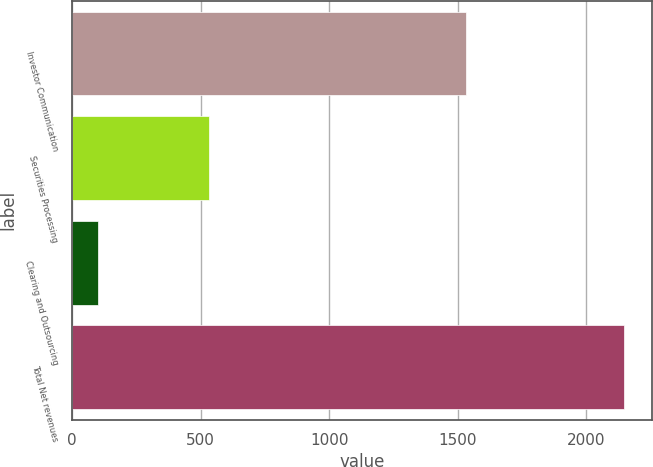<chart> <loc_0><loc_0><loc_500><loc_500><bar_chart><fcel>Investor Communication<fcel>Securities Processing<fcel>Clearing and Outsourcing<fcel>Total Net revenues<nl><fcel>1531<fcel>533.8<fcel>101.4<fcel>2149.3<nl></chart> 